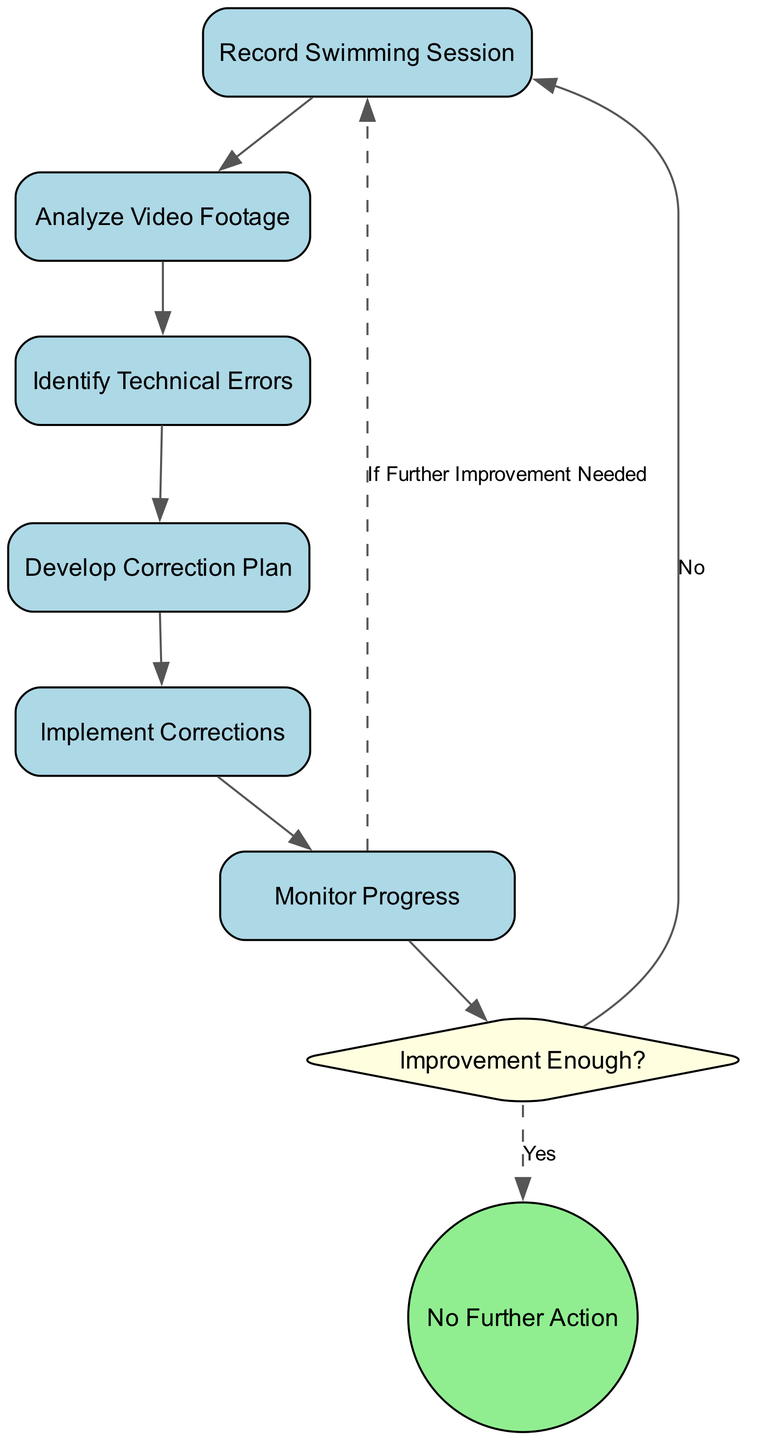What is the first activity in the process? The first activity in the process is indicated by the starting action, which is "Start Recording." This is the node that begins the flow of the diagram.
Answer: Start Recording How many main activities are depicted in the diagram? By counting the activity nodes defined in the data, we see that there are six main activities: "Record Swimming Session," "Analyze Video Footage," "Identify Technical Errors," "Develop Correction Plan," "Implement Corrections," and "Monitor Progress." Hence, there are six activities.
Answer: 6 What activity follows "Log Errors"? In the flow of the diagram, "Log Errors" is immediately followed by "Create Plan," as shown by the connecting arrow from "Log Errors" to "Create Plan."
Answer: Create Plan What is the condition upon which the flow returns to "Start Recording"? The flow returns to "Start Recording" if the condition "If Further Improvement Needed" is met. This indicates a loop back to the beginning of the recording process.
Answer: If Further Improvement Needed What happens if the improvement is sufficient? If the improvement is sufficient, as indicated by the decision point "Improvement Enough?" with a 'Yes' response, the process will lead to "No Further Action," meaning no additional steps will be taken for corrections.
Answer: No Further Action What is the last step in the improvement process? The last step in the improvement process, indicated by the end event node that concludes the flow of activities, is "No Further Action." This signifies the end of the current cycle.
Answer: No Further Action Which activity requires "Perform Drills"? The activity that requires "Perform Drills" follows the development of the correction plan. This means after creating the plan, the swimmer will carry out the drills specified in that plan.
Answer: Perform Drills Which activities lead to the decision point? The activities that lead to the decision point "Improvement Enough?" are "Monitor Progress," as it connects directly to the decision diamond. The flow suggests that monitoring leads to assessing the improvement.
Answer: Monitor Progress 